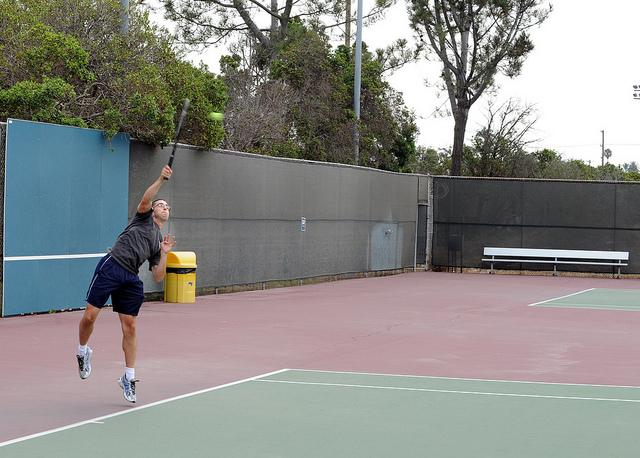Why is his arm raised so high? hit ball 